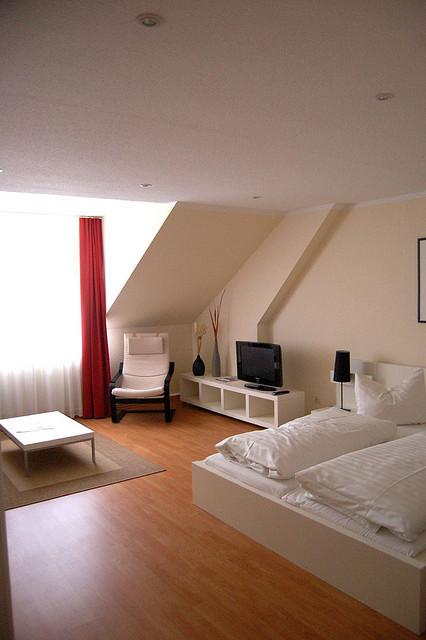How many watts does a night lamp use? 45 watts 